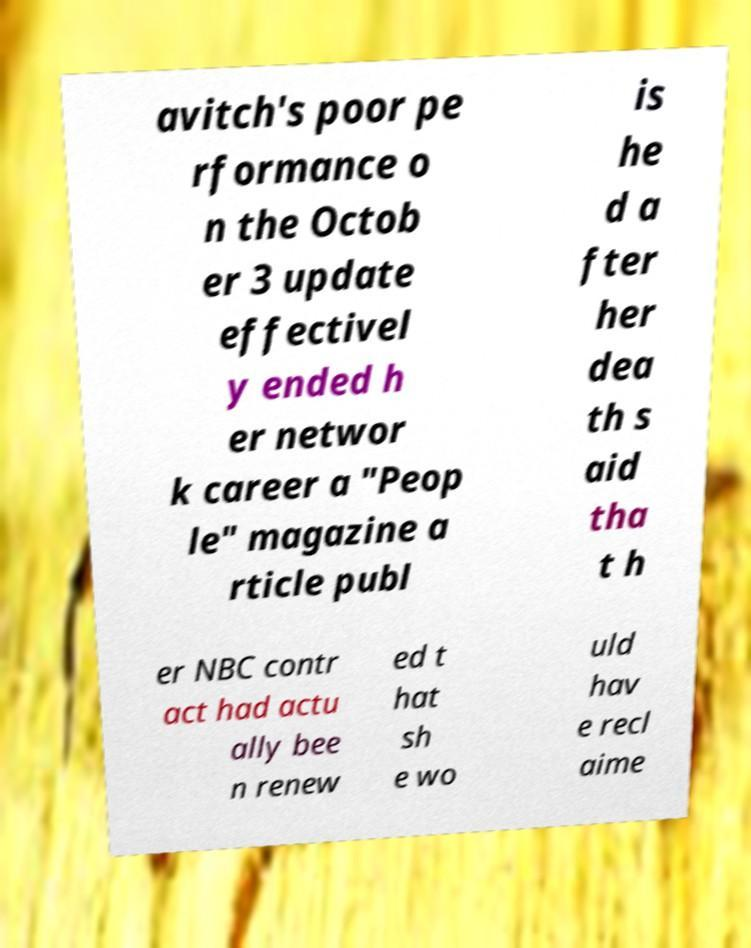For documentation purposes, I need the text within this image transcribed. Could you provide that? avitch's poor pe rformance o n the Octob er 3 update effectivel y ended h er networ k career a "Peop le" magazine a rticle publ is he d a fter her dea th s aid tha t h er NBC contr act had actu ally bee n renew ed t hat sh e wo uld hav e recl aime 